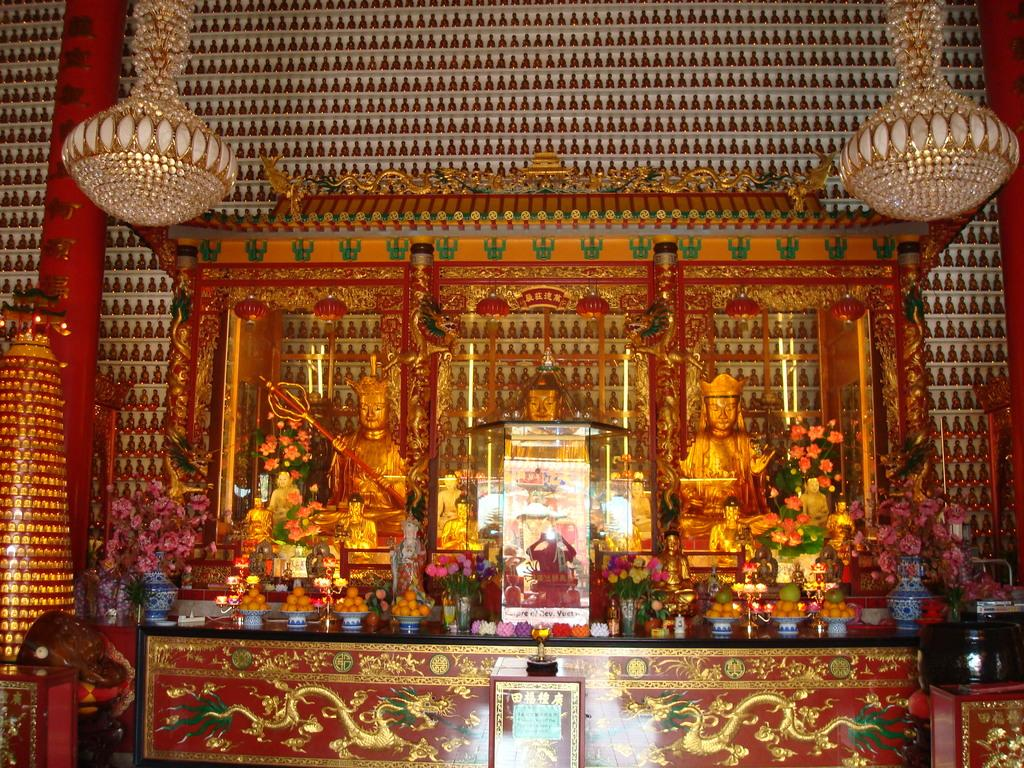What is located on the dais in the image? There are statues and flower pots on the dais in the image. What else can be seen on the dais? There is food on plates and candles present on the dais. What type of lighting is visible in the image? There are chandeliers visible in the image. How is the wall decorated in the image? The wall is decorated, but the specific decorations are not mentioned in the provided facts. What type of music is the band playing in the image? There is no band present in the image, so it is not possible to determine what type of music might be playing. 